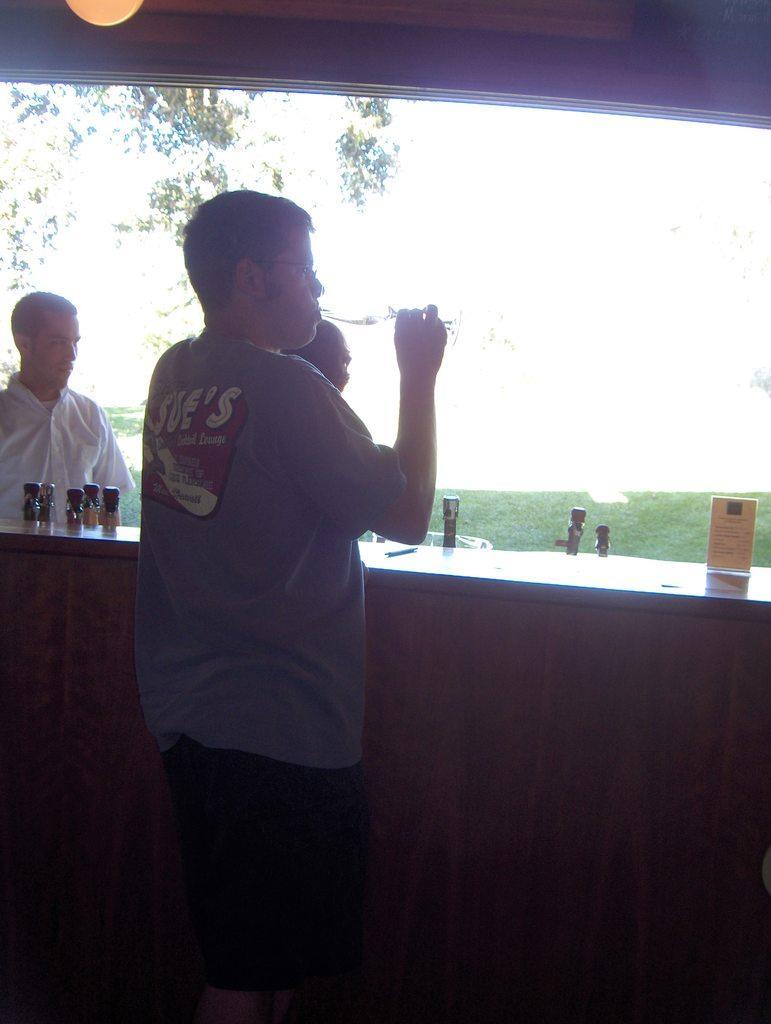How would you summarize this image in a sentence or two? In the picture I can see people are standing. Among them the man in the middle is holding something in the hand. I can also see some objects on a wooden surface. In the background I can see the sky and a tree. 